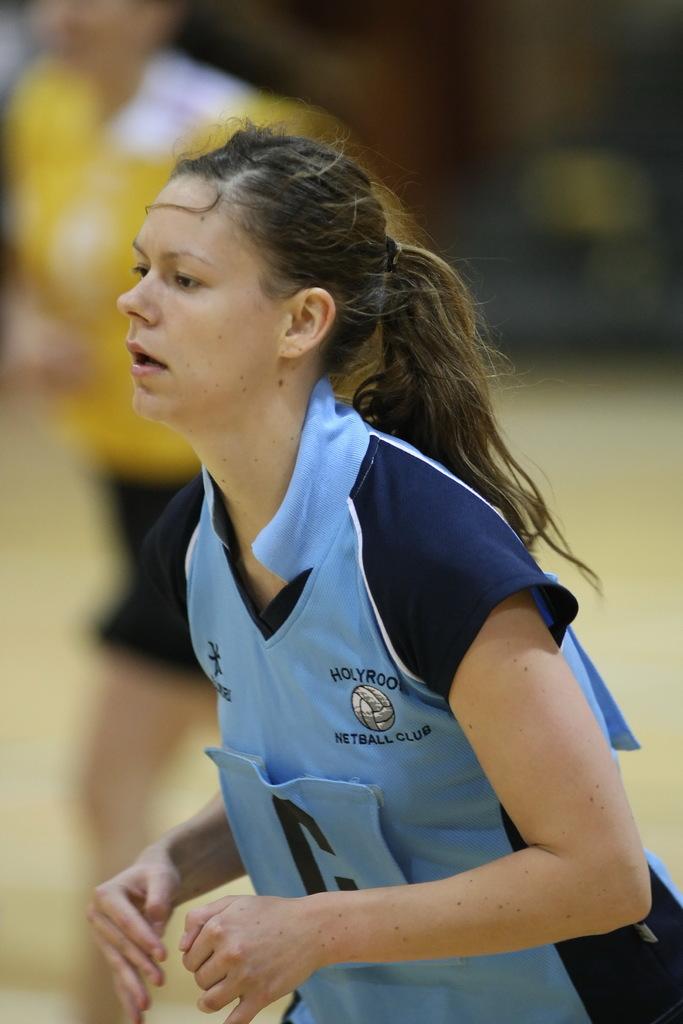What is the name of the club?
Make the answer very short. Holyrood netball club. 